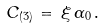<formula> <loc_0><loc_0><loc_500><loc_500>C _ { ( 3 ) } \, = \, \xi \, \alpha _ { 0 } \, .</formula> 